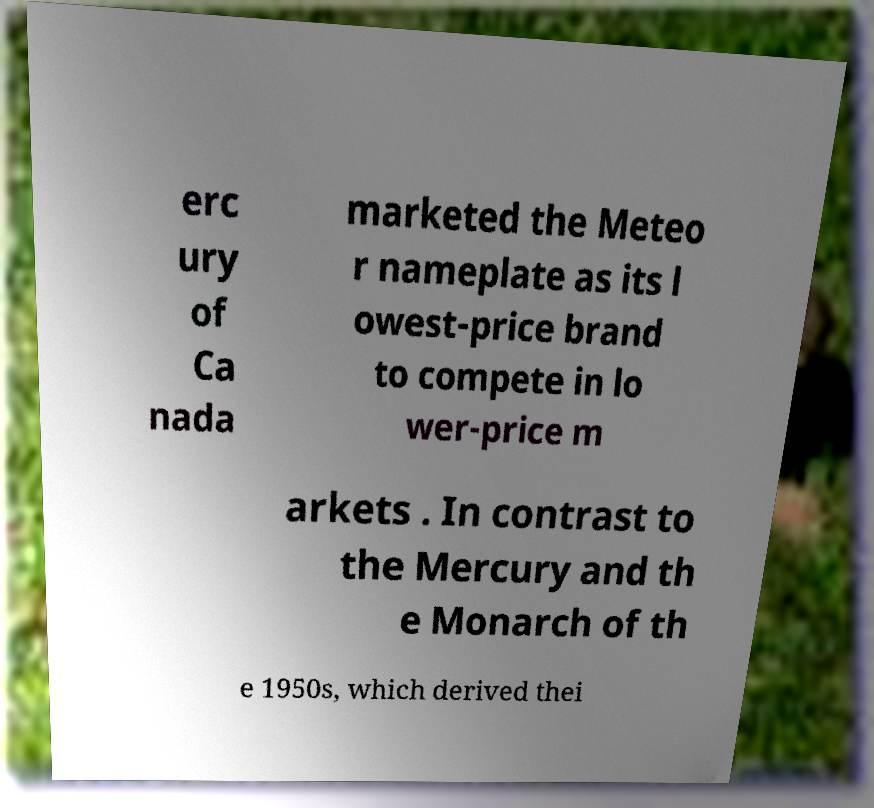Could you assist in decoding the text presented in this image and type it out clearly? erc ury of Ca nada marketed the Meteo r nameplate as its l owest-price brand to compete in lo wer-price m arkets . In contrast to the Mercury and th e Monarch of th e 1950s, which derived thei 